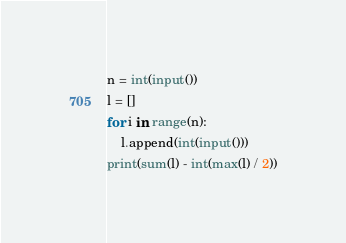Convert code to text. <code><loc_0><loc_0><loc_500><loc_500><_Python_>n = int(input())
l = []
for i in range(n):
    l.append(int(input()))
print(sum(l) - int(max(l) / 2))
</code> 